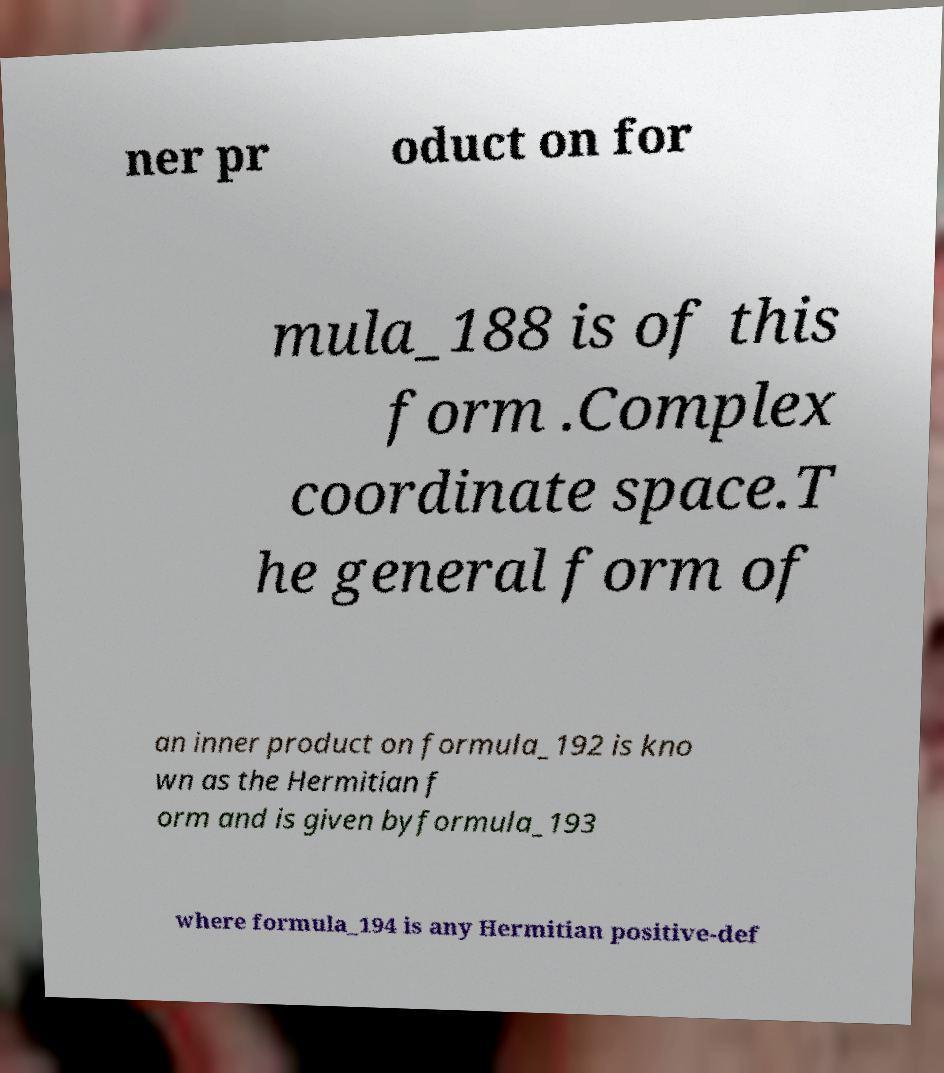There's text embedded in this image that I need extracted. Can you transcribe it verbatim? ner pr oduct on for mula_188 is of this form .Complex coordinate space.T he general form of an inner product on formula_192 is kno wn as the Hermitian f orm and is given byformula_193 where formula_194 is any Hermitian positive-def 